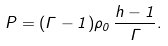<formula> <loc_0><loc_0><loc_500><loc_500>P = ( \Gamma - 1 ) \rho _ { 0 } \, \frac { h - 1 } { \Gamma } .</formula> 